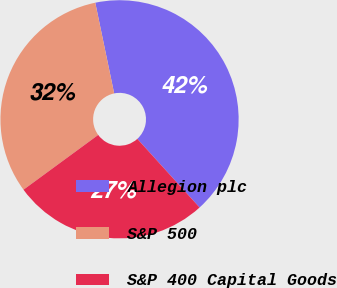Convert chart to OTSL. <chart><loc_0><loc_0><loc_500><loc_500><pie_chart><fcel>Allegion plc<fcel>S&P 500<fcel>S&P 400 Capital Goods<nl><fcel>41.54%<fcel>31.8%<fcel>26.66%<nl></chart> 